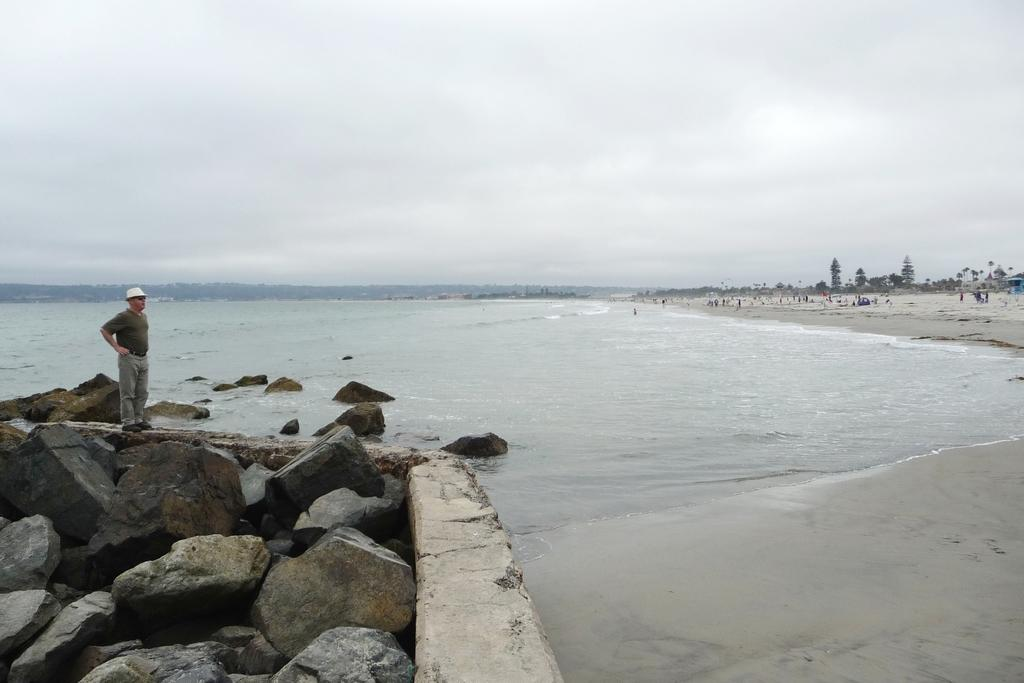What is located on the left side of the image? There is a man on the left side of the image. What is the man standing on? The man is on rocks. What can be seen in the center of the image? There is water in the center of the image. What type of vegetation is on the right side of the image? There are trees on the right side of the image. How many bikes are parked in front of the trees on the right side of the image? There are no bikes present in the image; it only features a man on rocks, water, and trees. 